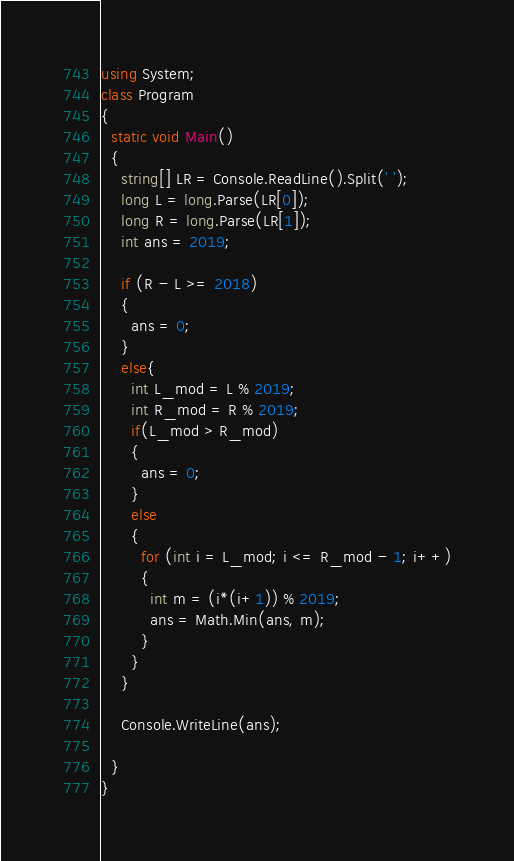Convert code to text. <code><loc_0><loc_0><loc_500><loc_500><_C#_>using System;
class Program
{
  static void Main()
  {
    string[] LR = Console.ReadLine().Split(' ');
    long L = long.Parse(LR[0]);
    long R = long.Parse(LR[1]);
    int ans = 2019;
    
    if (R - L >= 2018)
    {
      ans = 0;
    }
    else{
      int L_mod = L % 2019;
      int R_mod = R % 2019;
      if(L_mod > R_mod)
      {
        ans = 0;
      }
      else
      {
        for (int i = L_mod; i <= R_mod - 1; i++)
        {
          int m = (i*(i+1)) % 2019;
          ans = Math.Min(ans, m);
        }
      }
    }
    
    Console.WriteLine(ans);
    
  }
}
</code> 